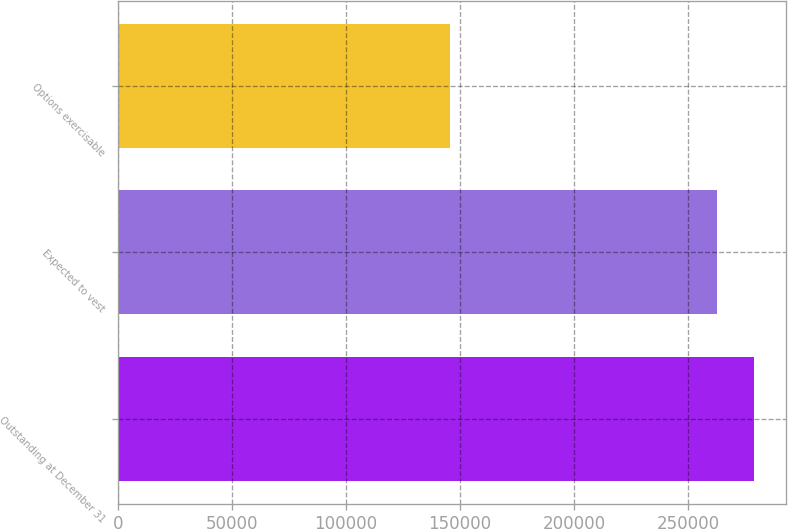Convert chart. <chart><loc_0><loc_0><loc_500><loc_500><bar_chart><fcel>Outstanding at December 31<fcel>Expected to vest<fcel>Options exercisable<nl><fcel>279229<fcel>262930<fcel>145841<nl></chart> 